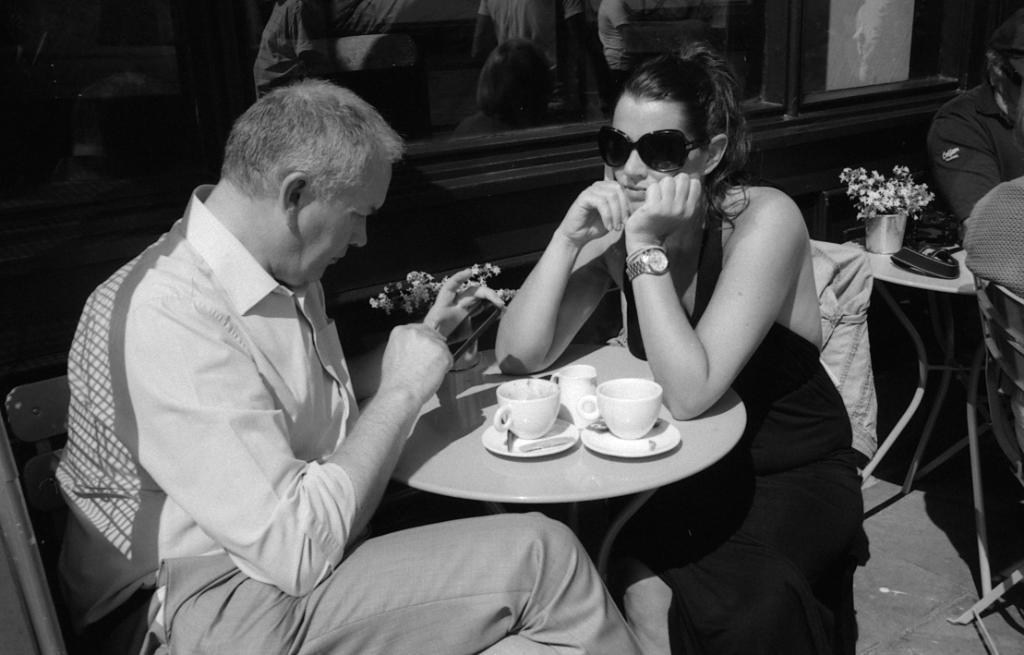In one or two sentences, can you explain what this image depicts? In the image we can see there is a black and white picture and there are two people who are sitting on chair and in front of them there is a table. There are cups and saucers on the table. 